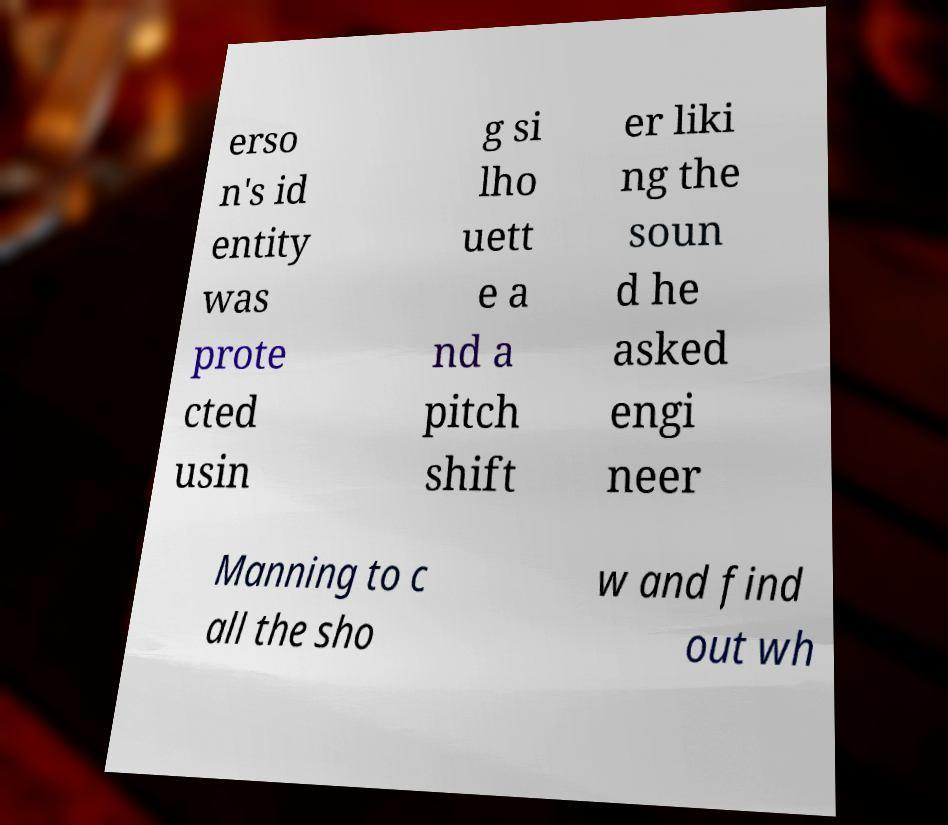Can you accurately transcribe the text from the provided image for me? erso n's id entity was prote cted usin g si lho uett e a nd a pitch shift er liki ng the soun d he asked engi neer Manning to c all the sho w and find out wh 